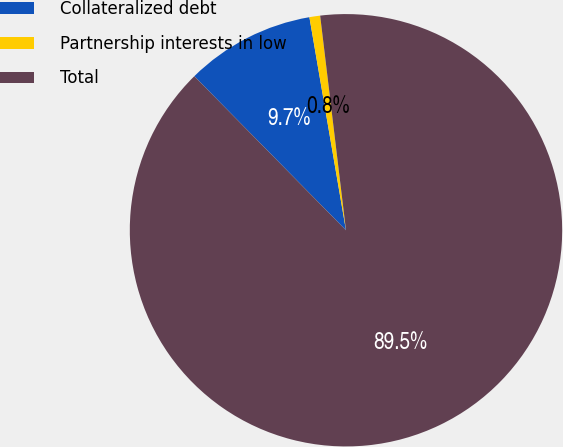Convert chart. <chart><loc_0><loc_0><loc_500><loc_500><pie_chart><fcel>Collateralized debt<fcel>Partnership interests in low<fcel>Total<nl><fcel>9.67%<fcel>0.8%<fcel>89.53%<nl></chart> 